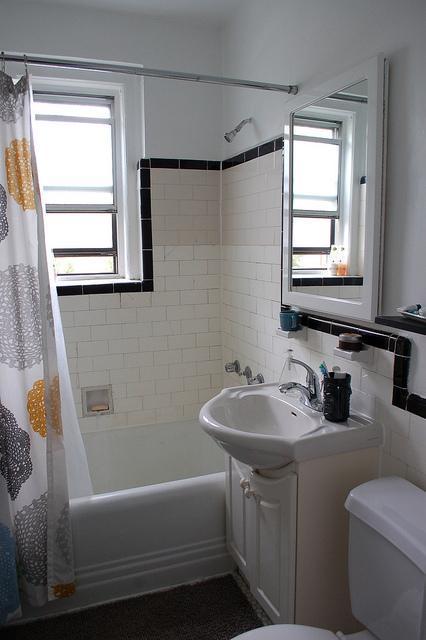How many sinks are there?
Give a very brief answer. 1. How many people have on sweaters?
Give a very brief answer. 0. 